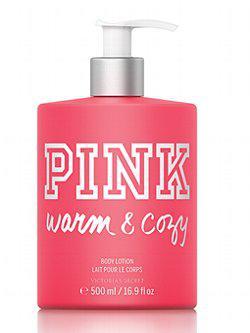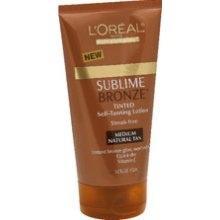The first image is the image on the left, the second image is the image on the right. Analyze the images presented: Is the assertion "Each image shows the same number of skincare products." valid? Answer yes or no. Yes. 